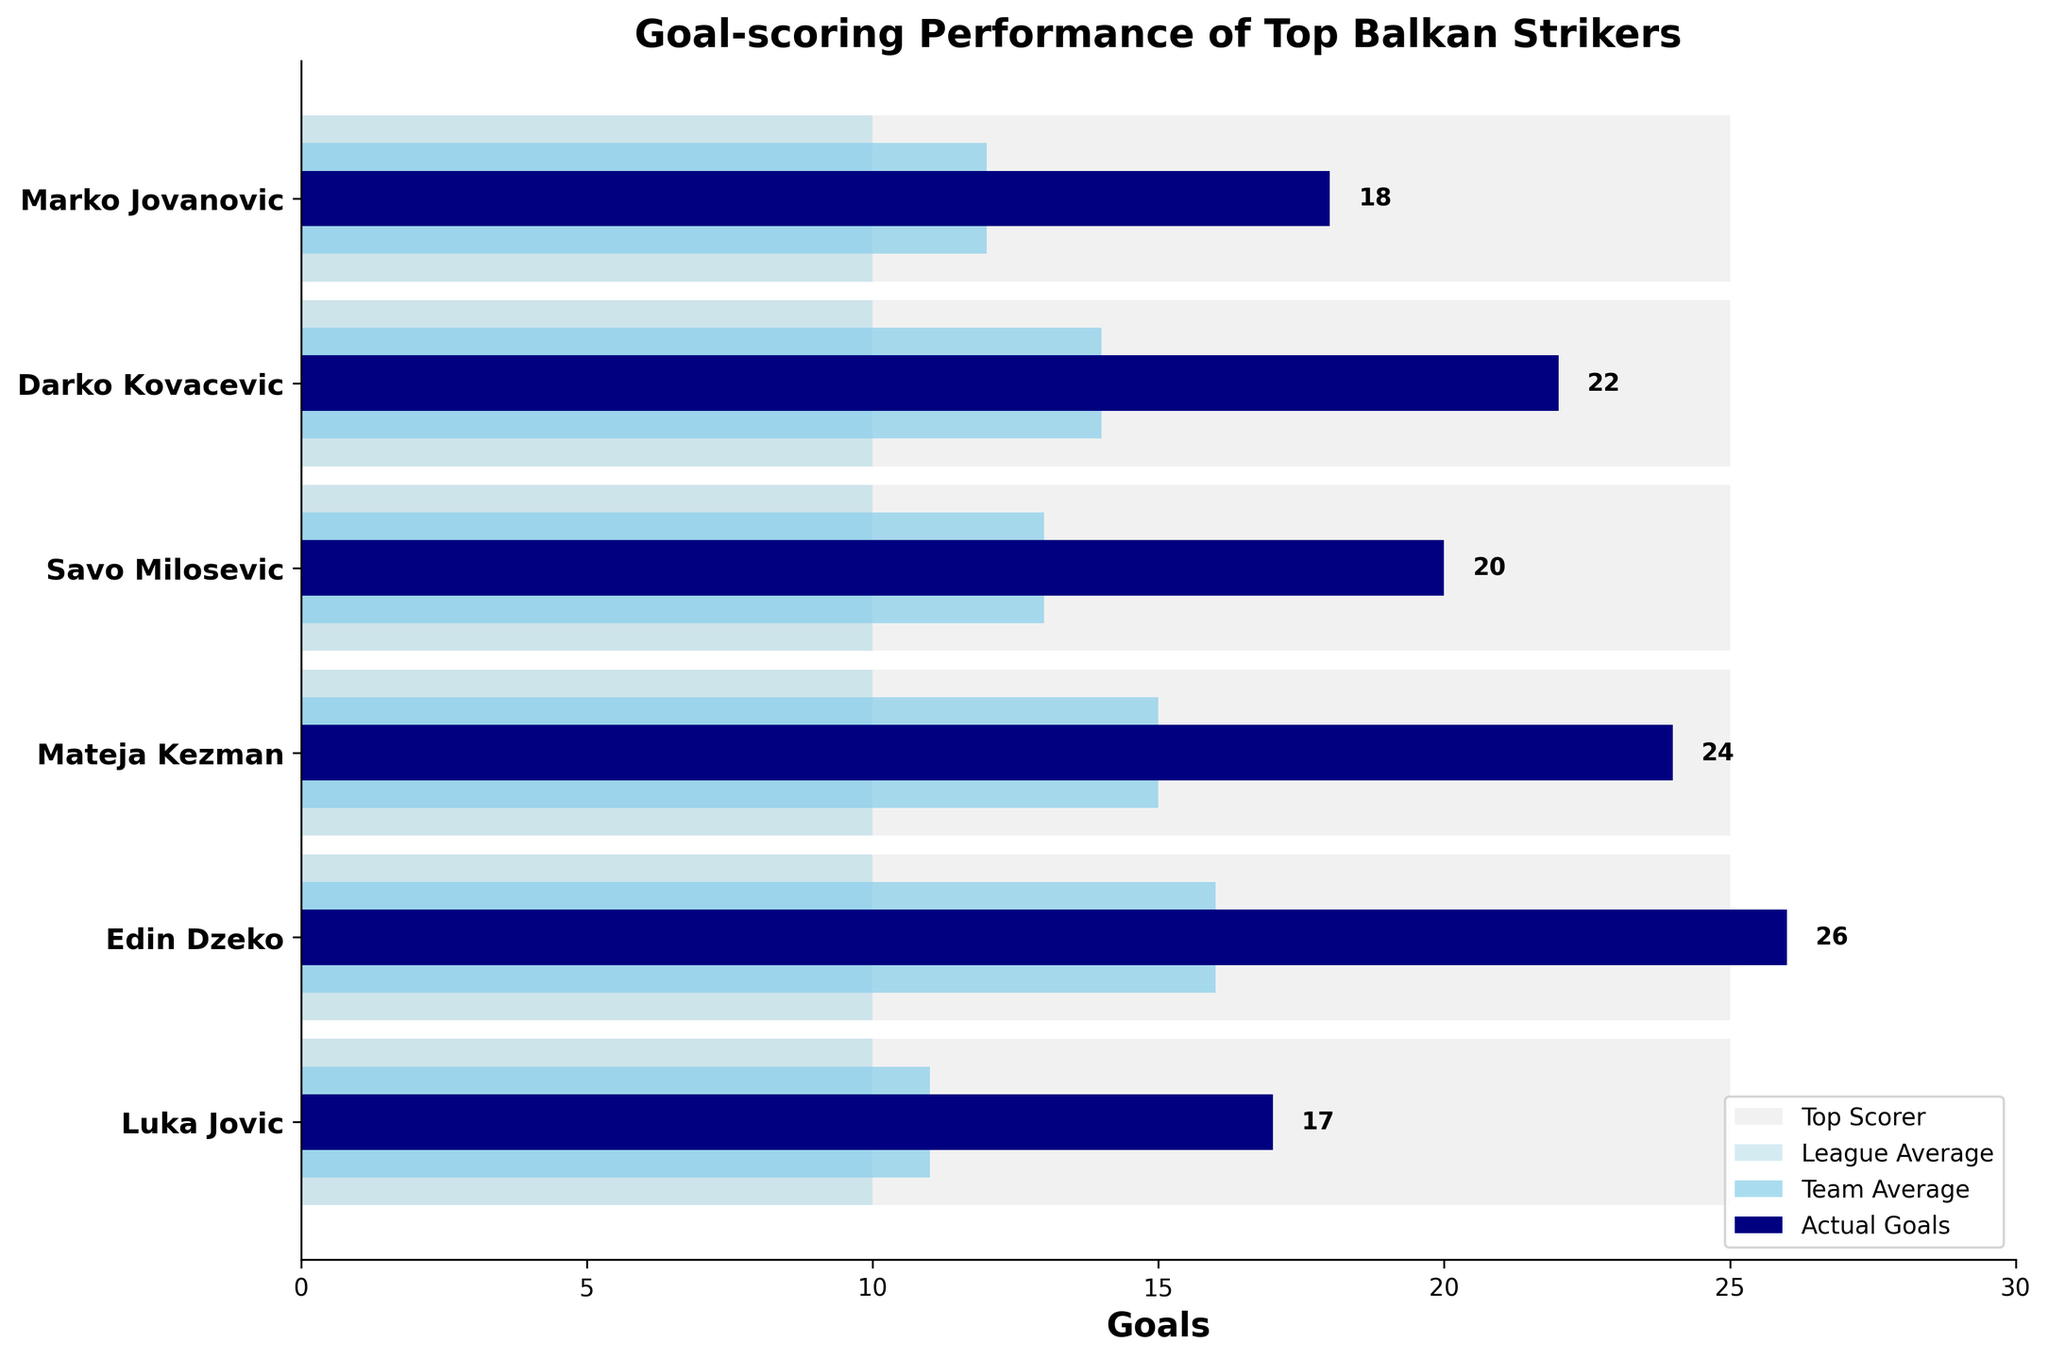what is the title of the chart? The title of the chart is displayed at the top.
Answer: Goal-scoring Performance of Top Balkan Strikers How many players are represented in this chart? The number of y-ticks corresponds to the number of players.
Answer: 6 Which player scored the most actual goals? Locate the bar with the highest value for actual goals (darkest bar).
Answer: Edin Dzeko What is the league average goal count? The league average is represented by the light blue bars for all players and is uniform across the chart.
Answer: 10 What is the difference between Mateja Kezman's actual goals and team average goals? Subtract the team average for Mateja Kezman from his actual goals (24 - 15).
Answer: 9 Which player has a team average below the league average? Look for a player's team average bar (skyblue) that is shorter than the league average bar (light blue).
Answer: Luka Jovic Compare Marko Jovanovic's actual goals with Edin Dzeko's team average. Who has a higher count? Compare the length of Marko Jovanovic's actual goals bar (navy) and Edin Dzeko's team average bar (skyblue).
Answer: Edin Dzeko How much higher is Darko Kovacevic's actual goals compared to the league average? Subtract the league average from Darko Kovacevic's actual goals (22 - 10).
Answer: 12 What is the average of the team averages for all players? Sum all team averages and divide by the number of players ((12 + 14 + 13 + 15 + 16 + 11) / 6).
Answer: 13.5 Which player comes closest to the top scorer's goal count without exceeding it? Compare each player's actual goals to the top scorer's bar (25), find the highest number below 25.
Answer: Edin Dzeko 